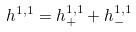Convert formula to latex. <formula><loc_0><loc_0><loc_500><loc_500>h ^ { 1 , 1 } = h _ { + } ^ { 1 , 1 } + h _ { - } ^ { 1 , 1 }</formula> 